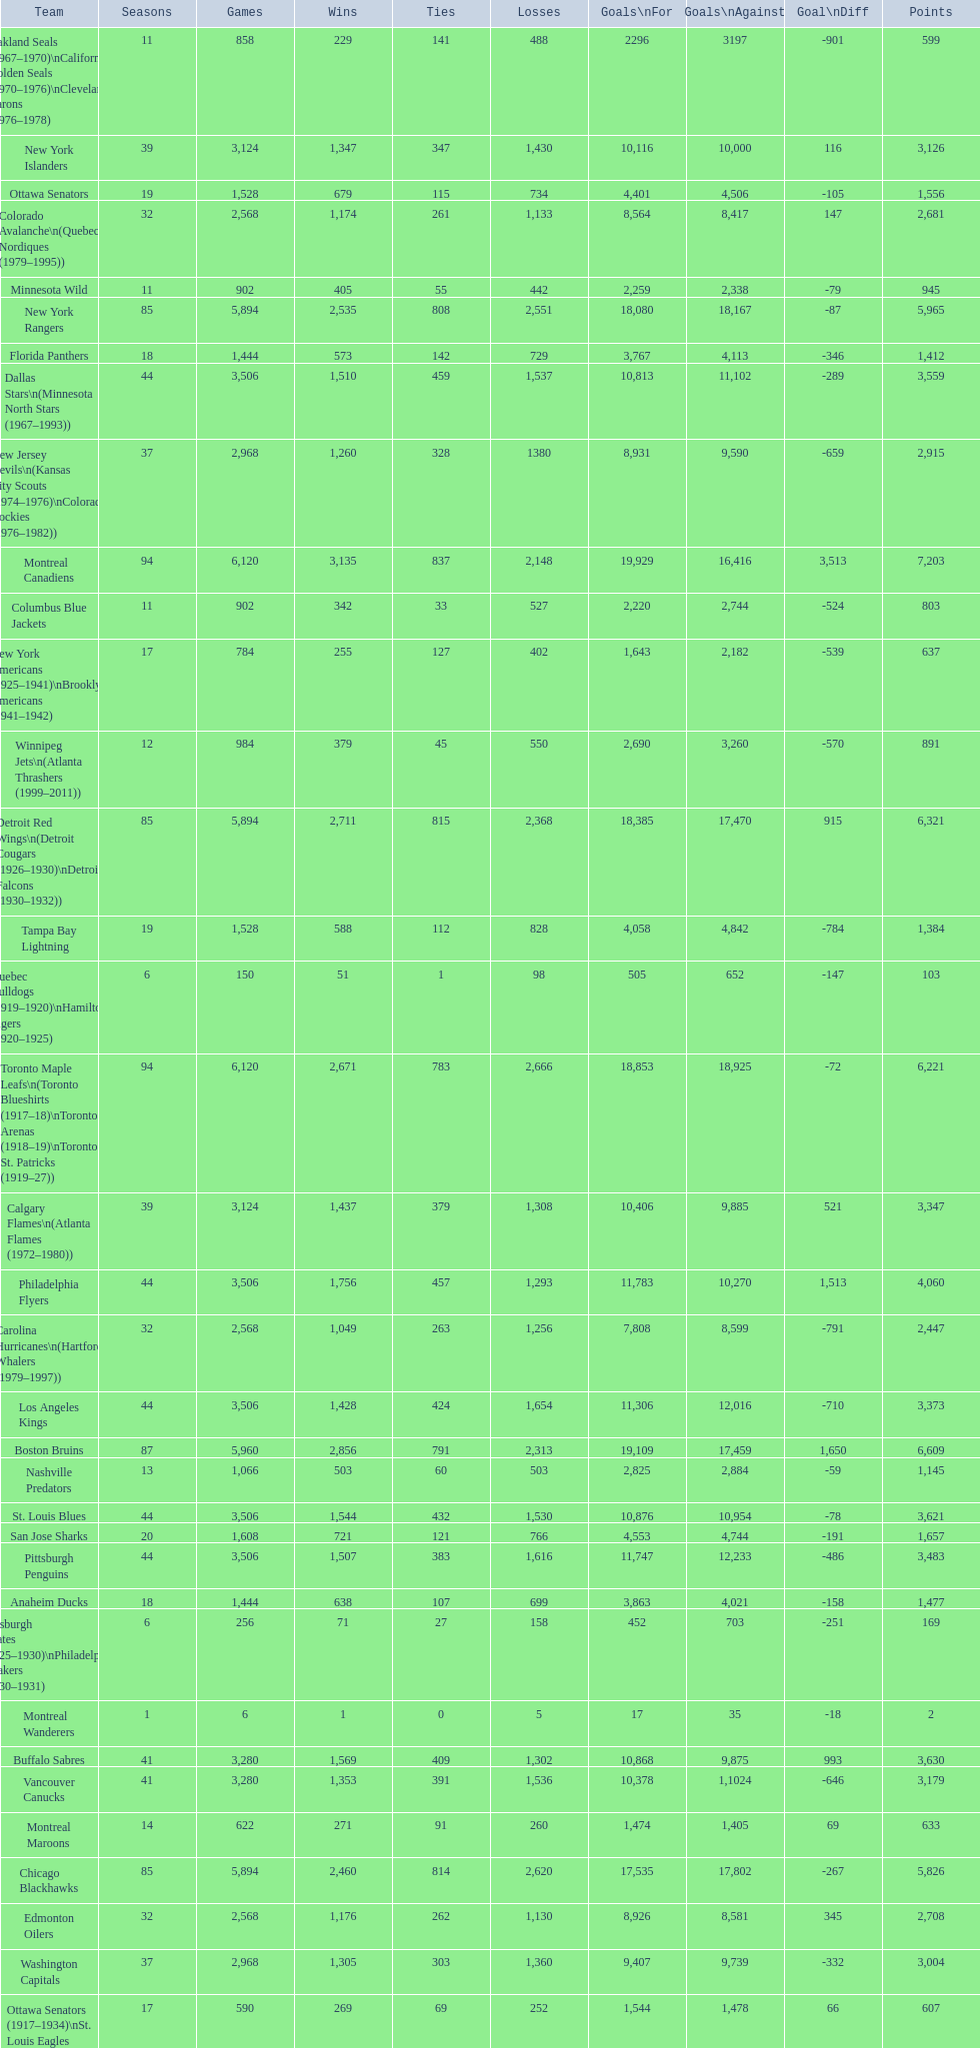What is the overall score of the los angeles kings? 3,373. 